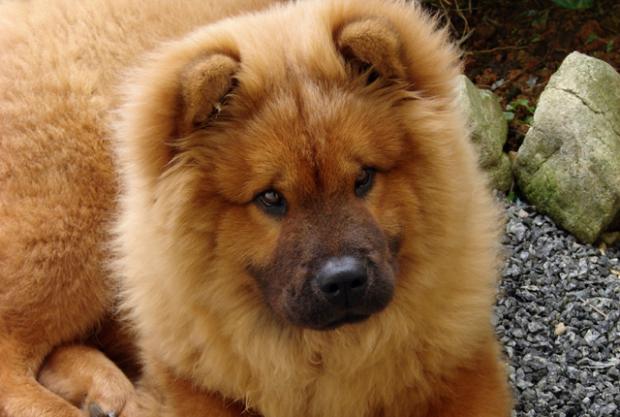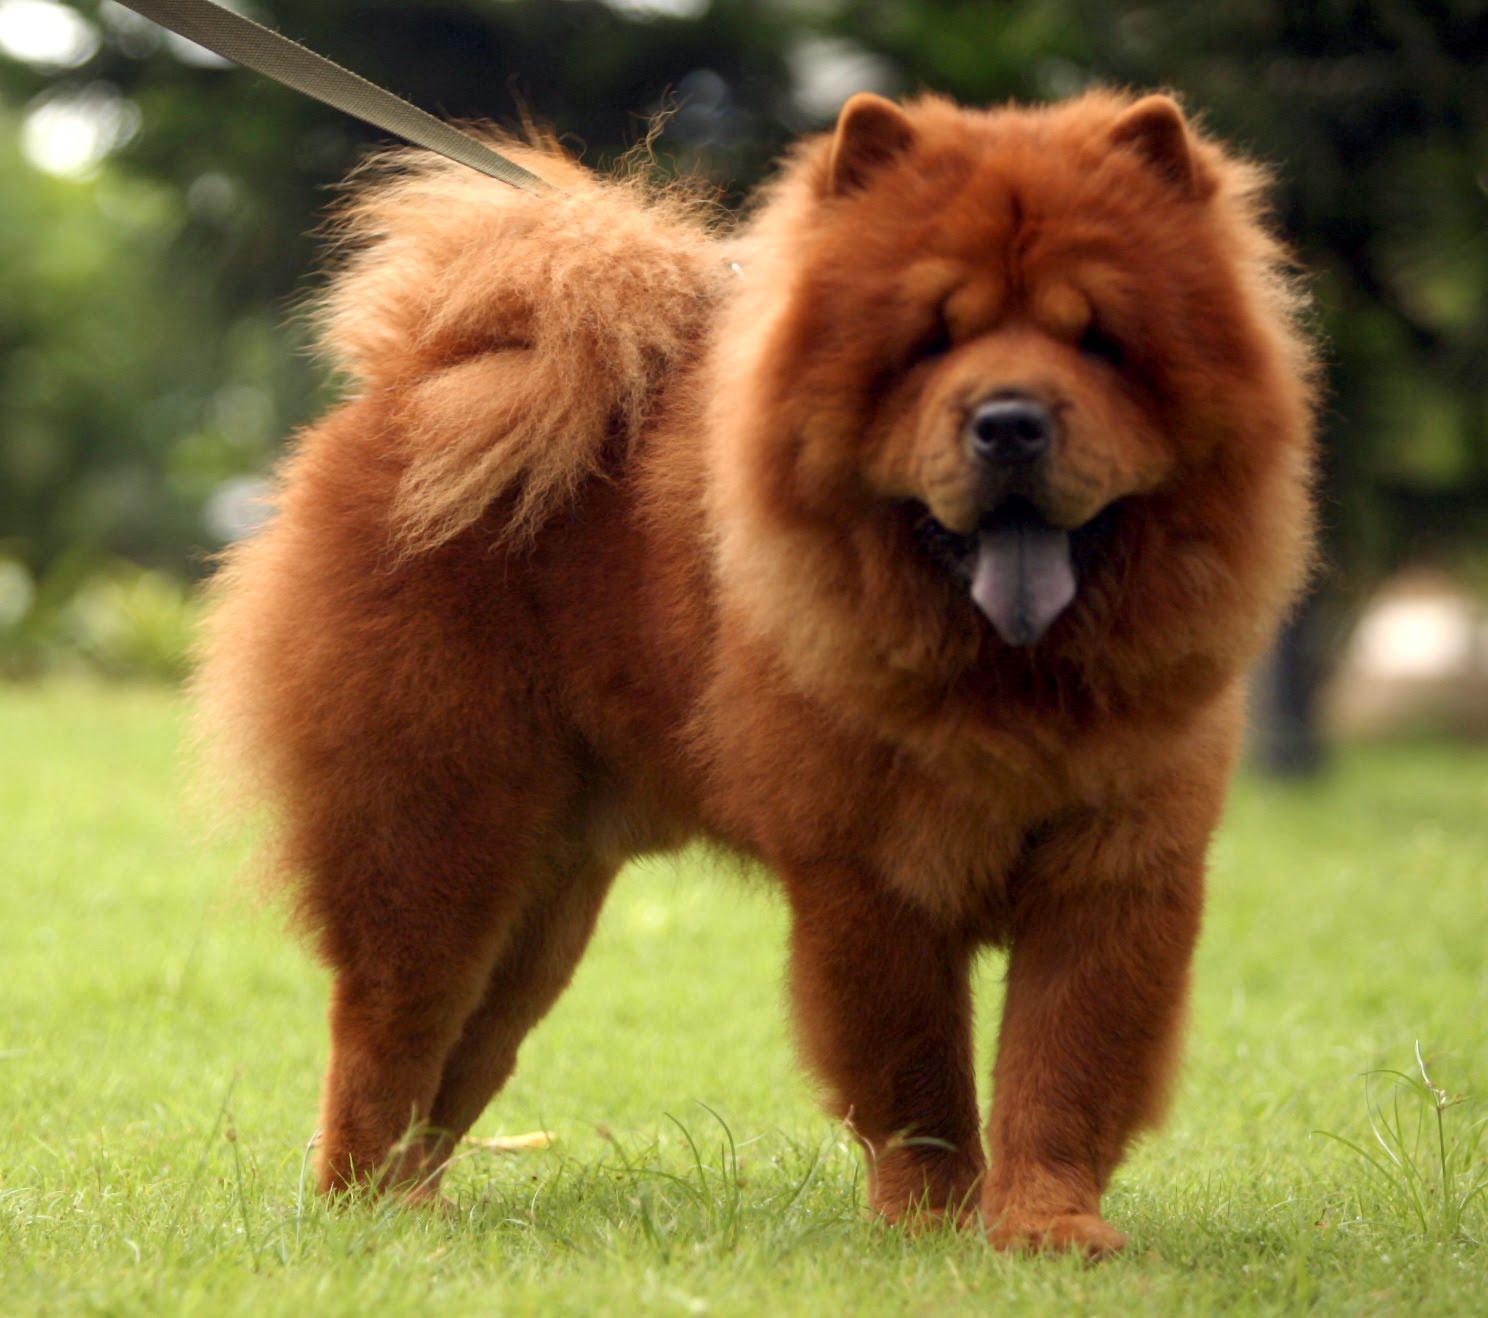The first image is the image on the left, the second image is the image on the right. Analyze the images presented: Is the assertion "A female is touching a dog with her hands." valid? Answer yes or no. No. The first image is the image on the left, the second image is the image on the right. Examine the images to the left and right. Is the description "The image on the left contains a person holding onto a dog." accurate? Answer yes or no. No. 